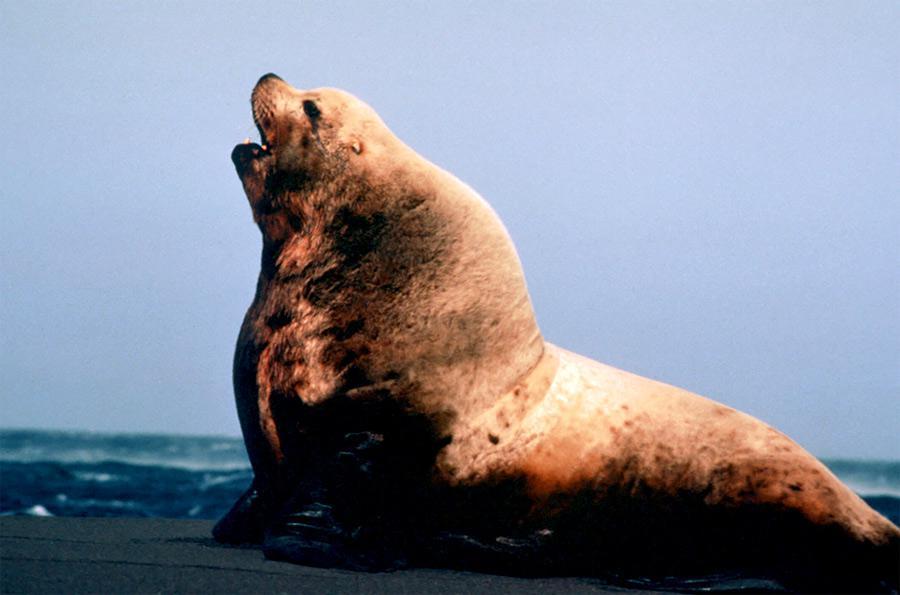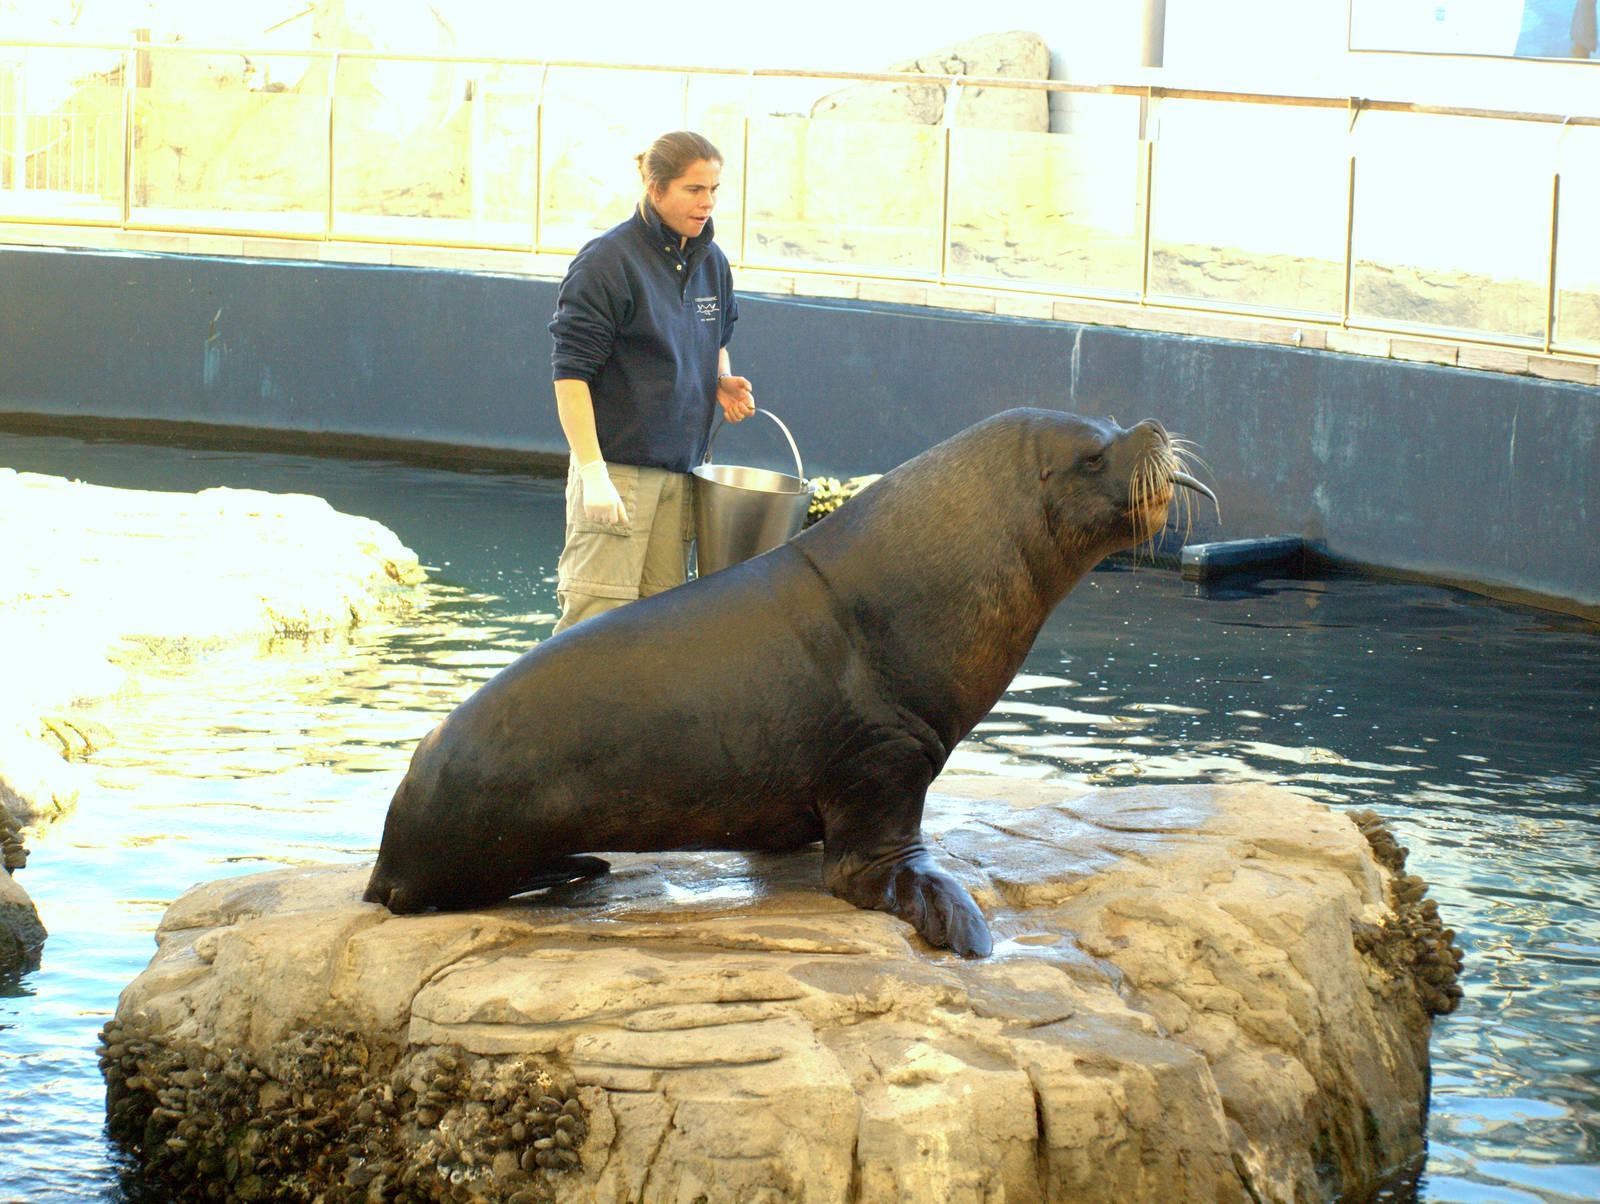The first image is the image on the left, the second image is the image on the right. Analyze the images presented: Is the assertion "One of the images is of a lone animal on a sandy beach." valid? Answer yes or no. No. The first image is the image on the left, the second image is the image on the right. Examine the images to the left and right. Is the description "One of the sea lions in on sand." accurate? Answer yes or no. No. 